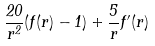Convert formula to latex. <formula><loc_0><loc_0><loc_500><loc_500>\frac { 2 0 } { r ^ { 2 } } ( f ( r ) - 1 ) + \frac { 5 } { r } f ^ { \prime } ( r )</formula> 